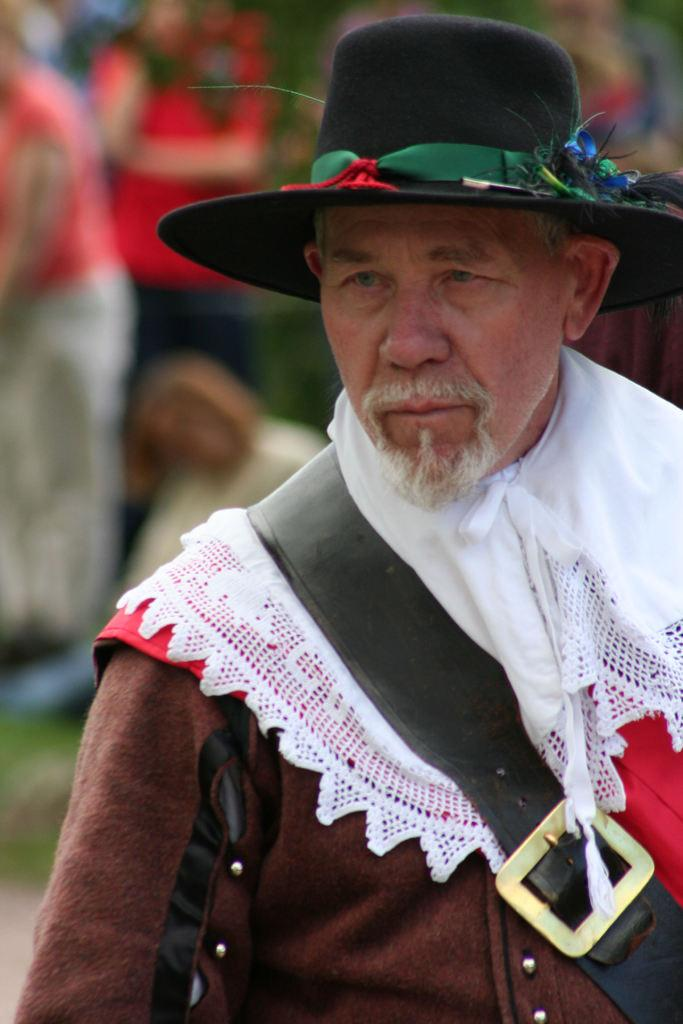Who is the main subject in the image? There is a man in the image. What is the man wearing on his head? The man is wearing a hat. Can you describe the people behind the man? The people behind the man are blurred. What type of tiger can be seen playing with a tank in the image? There is no tiger or tank present in the image; it features a man wearing a hat with blurred people behind him. How many cubs are visible in the image? There are no cubs present in the image. 